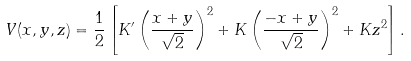<formula> <loc_0><loc_0><loc_500><loc_500>V ( x , y , z ) = \frac { 1 } { 2 } \left [ K ^ { \prime } \left ( \frac { x + y } { \sqrt { 2 } } \right ) ^ { 2 } + K \left ( \frac { - x + y } { \sqrt { 2 } } \right ) ^ { 2 } + K z ^ { 2 } \right ] .</formula> 